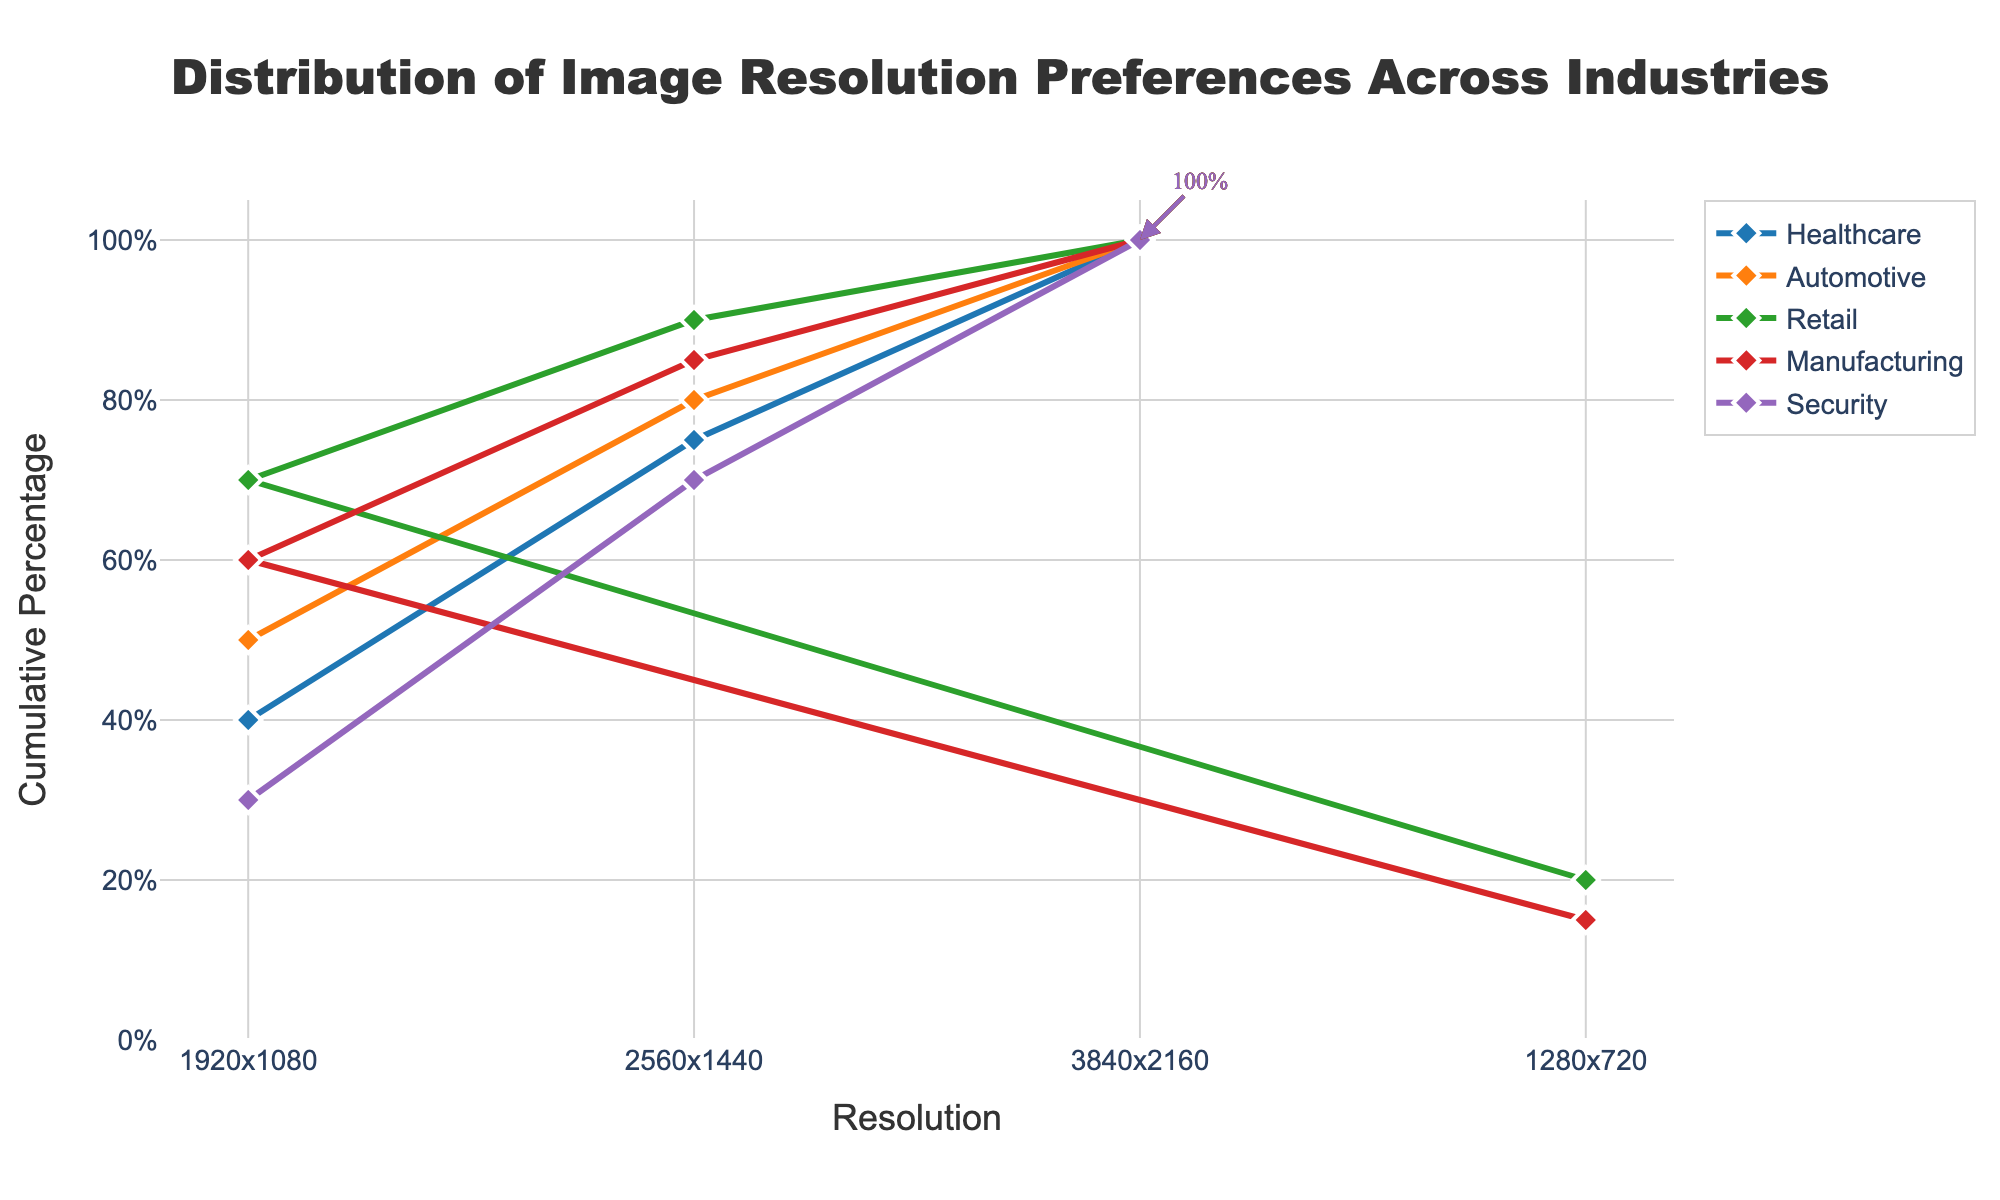What color is used to represent the Healthcare industry in the plot? The stair plot uses different colors for each industry to distinguish them. The Healthcare industry is represented by the first color in the color palette, which is blue.
Answer: Blue What is the cumulative percentage for the Security industry at 2560x1440 resolution? Locate the Security data line on the stair plot and find the 2560x1440 resolution on the x-axis. Follow the line vertically to the y-axis to read the cumulative percentage value.
Answer: 40% Which industry has the highest initial preference for 1920x1080 resolution? Identify the starting percentages for 1920x1080 resolution for each industry by looking at the leftmost cumulative percentage point for that resolution on the plot. Compare these values and find the highest one.
Answer: Automotive What is the total cumulative percentage for Manufacturing at its highest resolution? Locate the final point for the Manufacturing line on the plot, and observe the y-axis at that point to find the cumulative percentage. The highest resolution for Manufacturing is 3840x2160, and the cumulative percentage is 100%.
Answer: 100% How does Retail's preference for 1920x1080 resolution compare to Healthcare's preference for the same resolution? Identify the cumulative percentages for the 1920x1080 resolution for both Retail and Healthcare on the plot, then subtract the smaller percentage from the larger one to determine the difference.
Answer: Retail's preference is 10% higher than Healthcare's If you combine the preferences for 2560x1440 and 3840x2160 resolutions, which industry has the highest combined cumulative percentage? For each industry, add the cumulative percentages for 2560x1440 and 3840x2160 resolutions found on the y-axis of the plot. The industry with the highest total is the one with the highest combined cumulative percentage for these resolutions.
Answer: Healthcare Which industry shows the smallest difference in cumulative percentage between 1920x1080 and 2560x1440 resolutions? Calculate the difference between the cumulative percentages at 1920x1080 and 2560x1440 resolutions for each industry by subtracting the smaller percentage from the larger one. The industry with the smallest difference is the one with the smallest value.
Answer: Security What is the cumulative percentage at 1280x720 resolution for multiple industries combined? Only Retail and Manufacturing have preferences for 1280x720 resolution. Add their percentages to find the combined cumulative percentage: Retail (20%) + Manufacturing (15%) = 35%.
Answer: 35% Which industry has the steepest increase between any two consecutive resolution preferences? Observe the lines for each industry and identify the segments with the steepest slope, which occurs where there is the largest increase in cumulative percentage between two consecutive resolutions. Determine which industry has the steepest segment.
Answer: Automotive (between 1280x720 and 1920x1080) What is the most common highest resolution preference (3840x2160) percentage and which industries share it? Identify the cumulative percentages for 3840x2160 resolution in all industries. Determine the most common percentage value and list the industries sharing it.
Answer: 25%; Healthcare and Manufacturing 